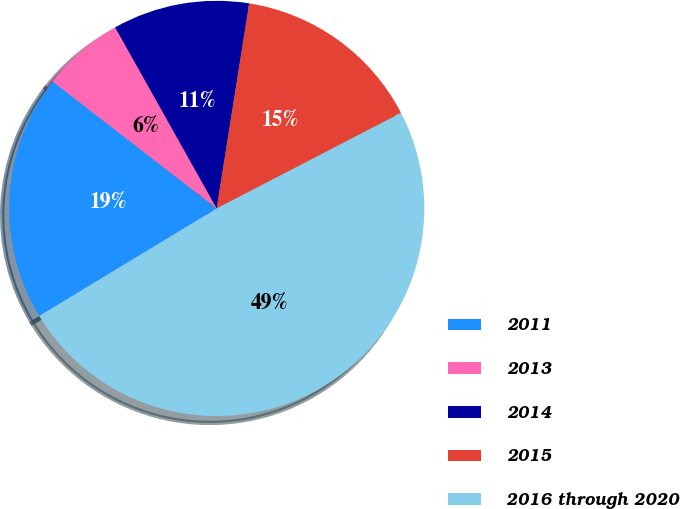Convert chart. <chart><loc_0><loc_0><loc_500><loc_500><pie_chart><fcel>2011<fcel>2013<fcel>2014<fcel>2015<fcel>2016 through 2020<nl><fcel>19.15%<fcel>6.38%<fcel>10.64%<fcel>14.89%<fcel>48.94%<nl></chart> 